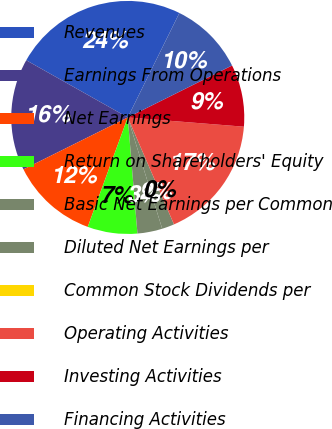Convert chart. <chart><loc_0><loc_0><loc_500><loc_500><pie_chart><fcel>Revenues<fcel>Earnings From Operations<fcel>Net Earnings<fcel>Return on Shareholders' Equity<fcel>Basic Net Earnings per Common<fcel>Diluted Net Earnings per<fcel>Common Stock Dividends per<fcel>Operating Activities<fcel>Investing Activities<fcel>Financing Activities<nl><fcel>24.14%<fcel>15.52%<fcel>12.07%<fcel>6.9%<fcel>3.45%<fcel>1.72%<fcel>0.0%<fcel>17.24%<fcel>8.62%<fcel>10.34%<nl></chart> 